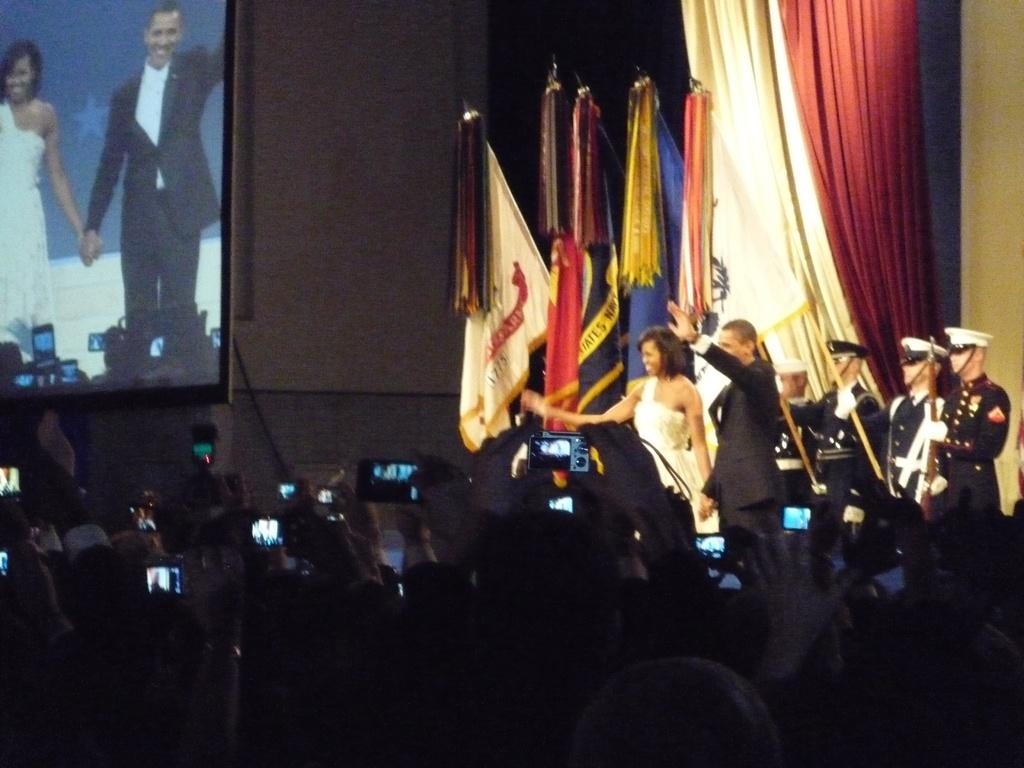How many people are present in the image? There are many people in the image. What are some people wearing in the image? Some people are wearing caps in the image. What are some people holding in the image? Some people are holding cameras in the image. What can be seen in the background of the image? There are flags and curtains in the image. What type of display device is present in the image? There is a screen in the image. What type of vest is being worn by the person holding the crown in the image? There is no person holding a crown in the image, and no one is wearing a vest. 